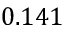<formula> <loc_0><loc_0><loc_500><loc_500>0 . 1 4 1</formula> 